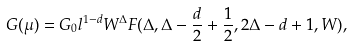Convert formula to latex. <formula><loc_0><loc_0><loc_500><loc_500>G ( \mu ) = G _ { 0 } l ^ { 1 - d } W ^ { \Delta } F ( \Delta , \Delta - \frac { d } { 2 } + \frac { 1 } { 2 } , 2 \Delta - d + 1 , W ) ,</formula> 